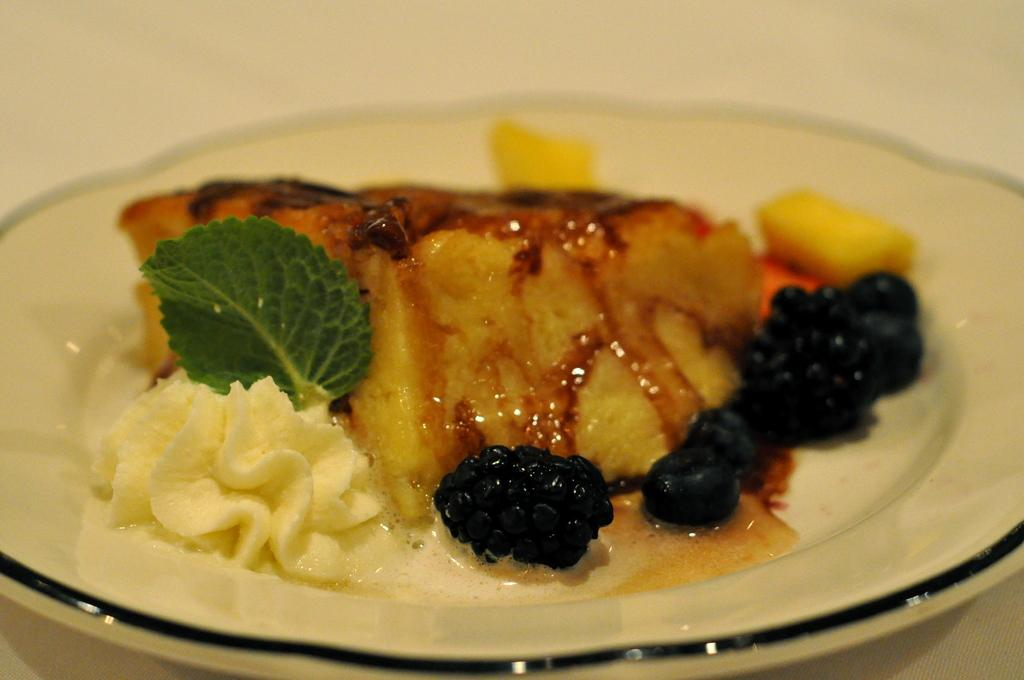What is present in the image that is related to plants? There is a leaf in the image. What type of food items can be seen on a plate in the image? The food items on the plate in the image are not specified, but they are present. Where is the plate with food items located in the image? The plate is placed on a surface in the image. Can you tell me how many hills are visible in the image? There are no hills present in the image. What type of cake is being served on the plate in the image? There is no cake present in the image; it features a leaf and food items on a plate. 